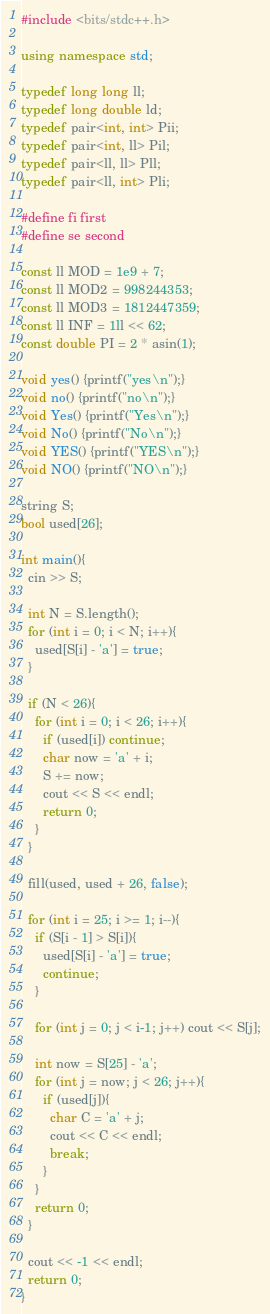<code> <loc_0><loc_0><loc_500><loc_500><_C++_>#include <bits/stdc++.h>

using namespace std;
 
typedef long long ll;
typedef long double ld;
typedef pair<int, int> Pii;
typedef pair<int, ll> Pil;
typedef pair<ll, ll> Pll;
typedef pair<ll, int> Pli;

#define fi first
#define se second

const ll MOD = 1e9 + 7;
const ll MOD2 = 998244353;
const ll MOD3 = 1812447359;
const ll INF = 1ll << 62;
const double PI = 2 * asin(1);

void yes() {printf("yes\n");}
void no() {printf("no\n");}
void Yes() {printf("Yes\n");}
void No() {printf("No\n");}
void YES() {printf("YES\n");}
void NO() {printf("NO\n");}

string S;
bool used[26];

int main(){
  cin >> S;

  int N = S.length();
  for (int i = 0; i < N; i++){
    used[S[i] - 'a'] = true;
  }

  if (N < 26){
    for (int i = 0; i < 26; i++){
      if (used[i]) continue;
      char now = 'a' + i;
      S += now;
      cout << S << endl;
      return 0;
    }
  }

  fill(used, used + 26, false);

  for (int i = 25; i >= 1; i--){
    if (S[i - 1] > S[i]){
      used[S[i] - 'a'] = true;
      continue;
    }
    
    for (int j = 0; j < i-1; j++) cout << S[j];

    int now = S[25] - 'a';
    for (int j = now; j < 26; j++){
      if (used[j]){
        char C = 'a' + j;
        cout << C << endl;
        break;
      }
    }
    return 0;
  }

  cout << -1 << endl;
  return 0;
}
</code> 